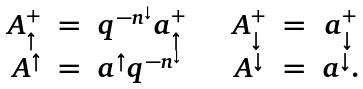<formula> <loc_0><loc_0><loc_500><loc_500>\begin{array} { r c l c r c l } A ^ { + } _ { \uparrow } & = & q ^ { - n ^ { \downarrow } } a ^ { + } _ { \uparrow } & \quad A ^ { + } _ { \downarrow } & = & a ^ { + } _ { \downarrow } \\ A ^ { \uparrow } & = & a ^ { \uparrow } q ^ { - n ^ { \downarrow } } & \quad A ^ { \downarrow } & = & a ^ { \downarrow } . \end{array}</formula> 